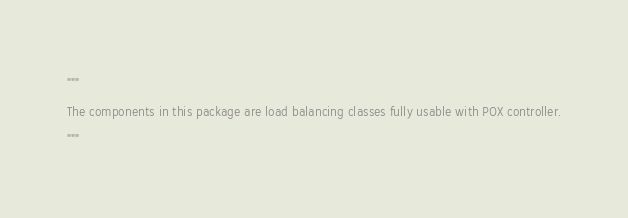Convert code to text. <code><loc_0><loc_0><loc_500><loc_500><_Python_>"""
The components in this package are load balancing classes fully usable with POX controller.
"""
</code> 